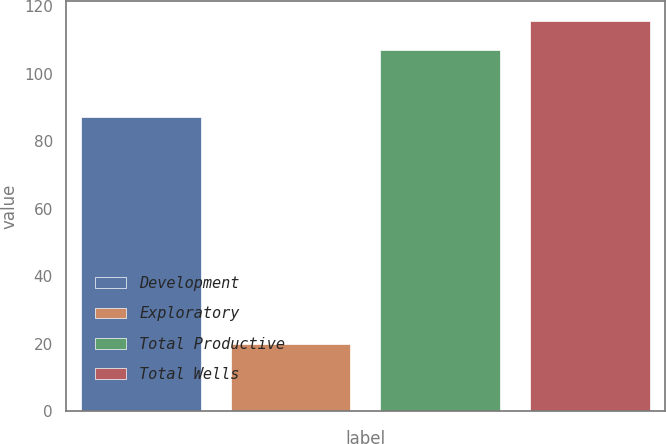Convert chart. <chart><loc_0><loc_0><loc_500><loc_500><bar_chart><fcel>Development<fcel>Exploratory<fcel>Total Productive<fcel>Total Wells<nl><fcel>87<fcel>20<fcel>107<fcel>115.7<nl></chart> 